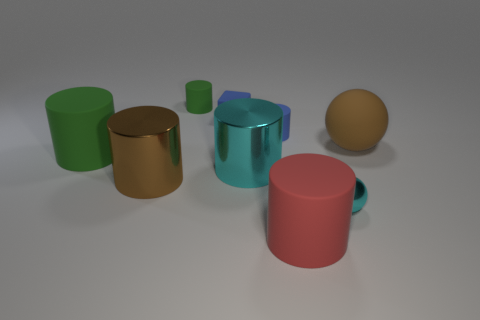Considering their size and proportions, how would you create a narrative around these objects? If we create a narrative, we could imagine these objects as sentient characters in a story set on a distant, minimalist planet. The sphere could be the wise elder of the group, the golden cylinder the strong and silent type, while the cups are the chatty socializers of this unique society, each with their own personality and role. 